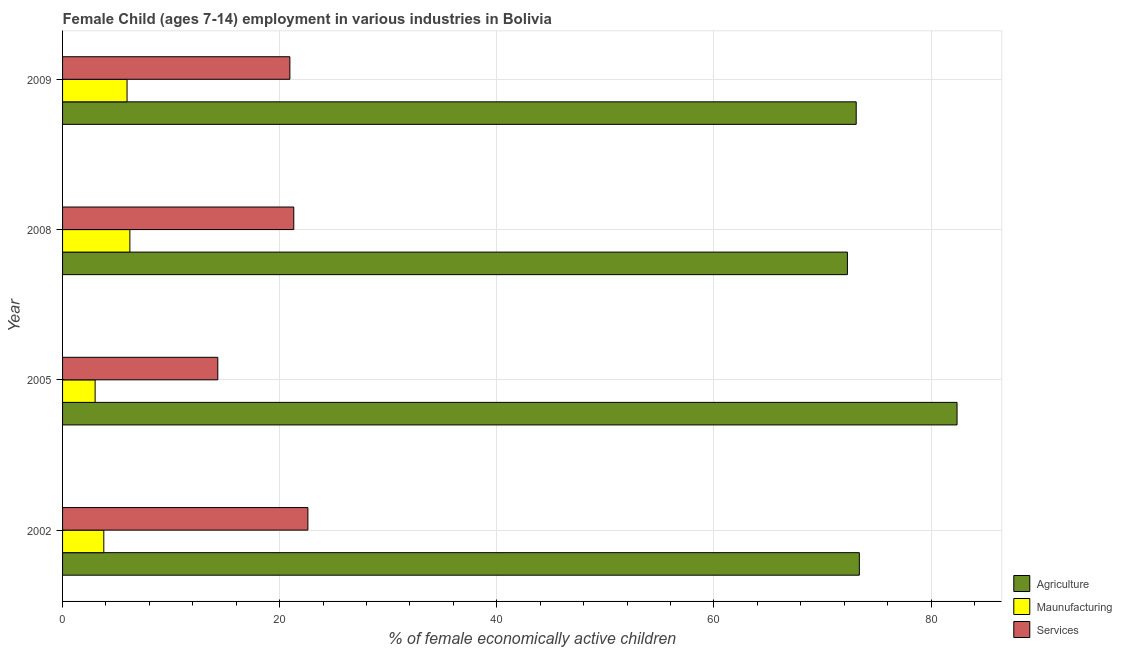How many different coloured bars are there?
Provide a short and direct response. 3. How many groups of bars are there?
Provide a succinct answer. 4. What is the label of the 1st group of bars from the top?
Your response must be concise. 2009. What is the percentage of economically active children in agriculture in 2009?
Keep it short and to the point. 73.11. Across all years, what is the maximum percentage of economically active children in manufacturing?
Give a very brief answer. 6.2. Across all years, what is the minimum percentage of economically active children in services?
Your answer should be very brief. 14.3. What is the total percentage of economically active children in services in the graph?
Provide a succinct answer. 79.14. What is the difference between the percentage of economically active children in services in 2002 and that in 2009?
Provide a succinct answer. 1.66. What is the difference between the percentage of economically active children in agriculture in 2008 and the percentage of economically active children in services in 2005?
Provide a short and direct response. 58. What is the average percentage of economically active children in services per year?
Keep it short and to the point. 19.79. In the year 2002, what is the difference between the percentage of economically active children in services and percentage of economically active children in agriculture?
Your answer should be compact. -50.8. In how many years, is the percentage of economically active children in services greater than 24 %?
Your response must be concise. 0. What is the ratio of the percentage of economically active children in services in 2002 to that in 2009?
Your answer should be compact. 1.08. Is the percentage of economically active children in manufacturing in 2002 less than that in 2005?
Ensure brevity in your answer.  No. Is the difference between the percentage of economically active children in services in 2002 and 2005 greater than the difference between the percentage of economically active children in manufacturing in 2002 and 2005?
Your answer should be compact. Yes. What does the 2nd bar from the top in 2009 represents?
Offer a very short reply. Maunufacturing. What does the 3rd bar from the bottom in 2009 represents?
Offer a very short reply. Services. Is it the case that in every year, the sum of the percentage of economically active children in agriculture and percentage of economically active children in manufacturing is greater than the percentage of economically active children in services?
Give a very brief answer. Yes. How many bars are there?
Your answer should be very brief. 12. Are all the bars in the graph horizontal?
Provide a short and direct response. Yes. Are the values on the major ticks of X-axis written in scientific E-notation?
Provide a succinct answer. No. Does the graph contain grids?
Your answer should be very brief. Yes. Where does the legend appear in the graph?
Provide a short and direct response. Bottom right. How many legend labels are there?
Make the answer very short. 3. What is the title of the graph?
Provide a short and direct response. Female Child (ages 7-14) employment in various industries in Bolivia. What is the label or title of the X-axis?
Provide a succinct answer. % of female economically active children. What is the % of female economically active children in Agriculture in 2002?
Provide a short and direct response. 73.4. What is the % of female economically active children of Maunufacturing in 2002?
Your answer should be compact. 3.8. What is the % of female economically active children of Services in 2002?
Provide a succinct answer. 22.6. What is the % of female economically active children in Agriculture in 2005?
Your answer should be very brief. 82.4. What is the % of female economically active children in Agriculture in 2008?
Your response must be concise. 72.3. What is the % of female economically active children of Maunufacturing in 2008?
Your answer should be very brief. 6.2. What is the % of female economically active children of Services in 2008?
Make the answer very short. 21.3. What is the % of female economically active children in Agriculture in 2009?
Your answer should be very brief. 73.11. What is the % of female economically active children of Maunufacturing in 2009?
Give a very brief answer. 5.94. What is the % of female economically active children in Services in 2009?
Give a very brief answer. 20.94. Across all years, what is the maximum % of female economically active children in Agriculture?
Offer a terse response. 82.4. Across all years, what is the maximum % of female economically active children in Maunufacturing?
Offer a terse response. 6.2. Across all years, what is the maximum % of female economically active children in Services?
Provide a succinct answer. 22.6. Across all years, what is the minimum % of female economically active children in Agriculture?
Give a very brief answer. 72.3. Across all years, what is the minimum % of female economically active children of Maunufacturing?
Offer a terse response. 3. What is the total % of female economically active children of Agriculture in the graph?
Your answer should be very brief. 301.21. What is the total % of female economically active children of Maunufacturing in the graph?
Ensure brevity in your answer.  18.94. What is the total % of female economically active children in Services in the graph?
Your response must be concise. 79.14. What is the difference between the % of female economically active children of Maunufacturing in 2002 and that in 2005?
Give a very brief answer. 0.8. What is the difference between the % of female economically active children of Services in 2002 and that in 2005?
Your answer should be very brief. 8.3. What is the difference between the % of female economically active children of Agriculture in 2002 and that in 2008?
Give a very brief answer. 1.1. What is the difference between the % of female economically active children in Maunufacturing in 2002 and that in 2008?
Ensure brevity in your answer.  -2.4. What is the difference between the % of female economically active children of Agriculture in 2002 and that in 2009?
Your response must be concise. 0.29. What is the difference between the % of female economically active children of Maunufacturing in 2002 and that in 2009?
Ensure brevity in your answer.  -2.14. What is the difference between the % of female economically active children of Services in 2002 and that in 2009?
Offer a terse response. 1.66. What is the difference between the % of female economically active children of Agriculture in 2005 and that in 2009?
Offer a very short reply. 9.29. What is the difference between the % of female economically active children of Maunufacturing in 2005 and that in 2009?
Ensure brevity in your answer.  -2.94. What is the difference between the % of female economically active children in Services in 2005 and that in 2009?
Give a very brief answer. -6.64. What is the difference between the % of female economically active children of Agriculture in 2008 and that in 2009?
Your answer should be compact. -0.81. What is the difference between the % of female economically active children of Maunufacturing in 2008 and that in 2009?
Ensure brevity in your answer.  0.26. What is the difference between the % of female economically active children in Services in 2008 and that in 2009?
Offer a very short reply. 0.36. What is the difference between the % of female economically active children of Agriculture in 2002 and the % of female economically active children of Maunufacturing in 2005?
Give a very brief answer. 70.4. What is the difference between the % of female economically active children of Agriculture in 2002 and the % of female economically active children of Services in 2005?
Your response must be concise. 59.1. What is the difference between the % of female economically active children of Agriculture in 2002 and the % of female economically active children of Maunufacturing in 2008?
Ensure brevity in your answer.  67.2. What is the difference between the % of female economically active children of Agriculture in 2002 and the % of female economically active children of Services in 2008?
Offer a very short reply. 52.1. What is the difference between the % of female economically active children of Maunufacturing in 2002 and the % of female economically active children of Services in 2008?
Your answer should be very brief. -17.5. What is the difference between the % of female economically active children of Agriculture in 2002 and the % of female economically active children of Maunufacturing in 2009?
Offer a terse response. 67.46. What is the difference between the % of female economically active children in Agriculture in 2002 and the % of female economically active children in Services in 2009?
Provide a succinct answer. 52.46. What is the difference between the % of female economically active children of Maunufacturing in 2002 and the % of female economically active children of Services in 2009?
Your answer should be very brief. -17.14. What is the difference between the % of female economically active children in Agriculture in 2005 and the % of female economically active children in Maunufacturing in 2008?
Offer a terse response. 76.2. What is the difference between the % of female economically active children in Agriculture in 2005 and the % of female economically active children in Services in 2008?
Ensure brevity in your answer.  61.1. What is the difference between the % of female economically active children in Maunufacturing in 2005 and the % of female economically active children in Services in 2008?
Your answer should be compact. -18.3. What is the difference between the % of female economically active children of Agriculture in 2005 and the % of female economically active children of Maunufacturing in 2009?
Your answer should be very brief. 76.46. What is the difference between the % of female economically active children of Agriculture in 2005 and the % of female economically active children of Services in 2009?
Offer a terse response. 61.46. What is the difference between the % of female economically active children in Maunufacturing in 2005 and the % of female economically active children in Services in 2009?
Ensure brevity in your answer.  -17.94. What is the difference between the % of female economically active children of Agriculture in 2008 and the % of female economically active children of Maunufacturing in 2009?
Provide a short and direct response. 66.36. What is the difference between the % of female economically active children in Agriculture in 2008 and the % of female economically active children in Services in 2009?
Give a very brief answer. 51.36. What is the difference between the % of female economically active children in Maunufacturing in 2008 and the % of female economically active children in Services in 2009?
Offer a very short reply. -14.74. What is the average % of female economically active children of Agriculture per year?
Keep it short and to the point. 75.3. What is the average % of female economically active children in Maunufacturing per year?
Provide a short and direct response. 4.74. What is the average % of female economically active children in Services per year?
Offer a terse response. 19.79. In the year 2002, what is the difference between the % of female economically active children of Agriculture and % of female economically active children of Maunufacturing?
Your answer should be very brief. 69.6. In the year 2002, what is the difference between the % of female economically active children in Agriculture and % of female economically active children in Services?
Make the answer very short. 50.8. In the year 2002, what is the difference between the % of female economically active children in Maunufacturing and % of female economically active children in Services?
Your response must be concise. -18.8. In the year 2005, what is the difference between the % of female economically active children of Agriculture and % of female economically active children of Maunufacturing?
Keep it short and to the point. 79.4. In the year 2005, what is the difference between the % of female economically active children of Agriculture and % of female economically active children of Services?
Your answer should be compact. 68.1. In the year 2008, what is the difference between the % of female economically active children in Agriculture and % of female economically active children in Maunufacturing?
Your answer should be very brief. 66.1. In the year 2008, what is the difference between the % of female economically active children of Maunufacturing and % of female economically active children of Services?
Your answer should be very brief. -15.1. In the year 2009, what is the difference between the % of female economically active children of Agriculture and % of female economically active children of Maunufacturing?
Keep it short and to the point. 67.17. In the year 2009, what is the difference between the % of female economically active children in Agriculture and % of female economically active children in Services?
Your response must be concise. 52.17. What is the ratio of the % of female economically active children of Agriculture in 2002 to that in 2005?
Provide a short and direct response. 0.89. What is the ratio of the % of female economically active children in Maunufacturing in 2002 to that in 2005?
Your answer should be compact. 1.27. What is the ratio of the % of female economically active children of Services in 2002 to that in 2005?
Your response must be concise. 1.58. What is the ratio of the % of female economically active children in Agriculture in 2002 to that in 2008?
Offer a very short reply. 1.02. What is the ratio of the % of female economically active children of Maunufacturing in 2002 to that in 2008?
Make the answer very short. 0.61. What is the ratio of the % of female economically active children in Services in 2002 to that in 2008?
Provide a succinct answer. 1.06. What is the ratio of the % of female economically active children of Agriculture in 2002 to that in 2009?
Your answer should be compact. 1. What is the ratio of the % of female economically active children in Maunufacturing in 2002 to that in 2009?
Keep it short and to the point. 0.64. What is the ratio of the % of female economically active children in Services in 2002 to that in 2009?
Your answer should be compact. 1.08. What is the ratio of the % of female economically active children of Agriculture in 2005 to that in 2008?
Provide a short and direct response. 1.14. What is the ratio of the % of female economically active children of Maunufacturing in 2005 to that in 2008?
Ensure brevity in your answer.  0.48. What is the ratio of the % of female economically active children in Services in 2005 to that in 2008?
Give a very brief answer. 0.67. What is the ratio of the % of female economically active children of Agriculture in 2005 to that in 2009?
Offer a terse response. 1.13. What is the ratio of the % of female economically active children in Maunufacturing in 2005 to that in 2009?
Your answer should be compact. 0.51. What is the ratio of the % of female economically active children in Services in 2005 to that in 2009?
Provide a short and direct response. 0.68. What is the ratio of the % of female economically active children of Agriculture in 2008 to that in 2009?
Your answer should be very brief. 0.99. What is the ratio of the % of female economically active children of Maunufacturing in 2008 to that in 2009?
Provide a succinct answer. 1.04. What is the ratio of the % of female economically active children of Services in 2008 to that in 2009?
Give a very brief answer. 1.02. What is the difference between the highest and the second highest % of female economically active children in Agriculture?
Your answer should be compact. 9. What is the difference between the highest and the second highest % of female economically active children of Maunufacturing?
Your answer should be very brief. 0.26. What is the difference between the highest and the lowest % of female economically active children of Services?
Keep it short and to the point. 8.3. 